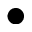<formula> <loc_0><loc_0><loc_500><loc_500>\bullet</formula> 